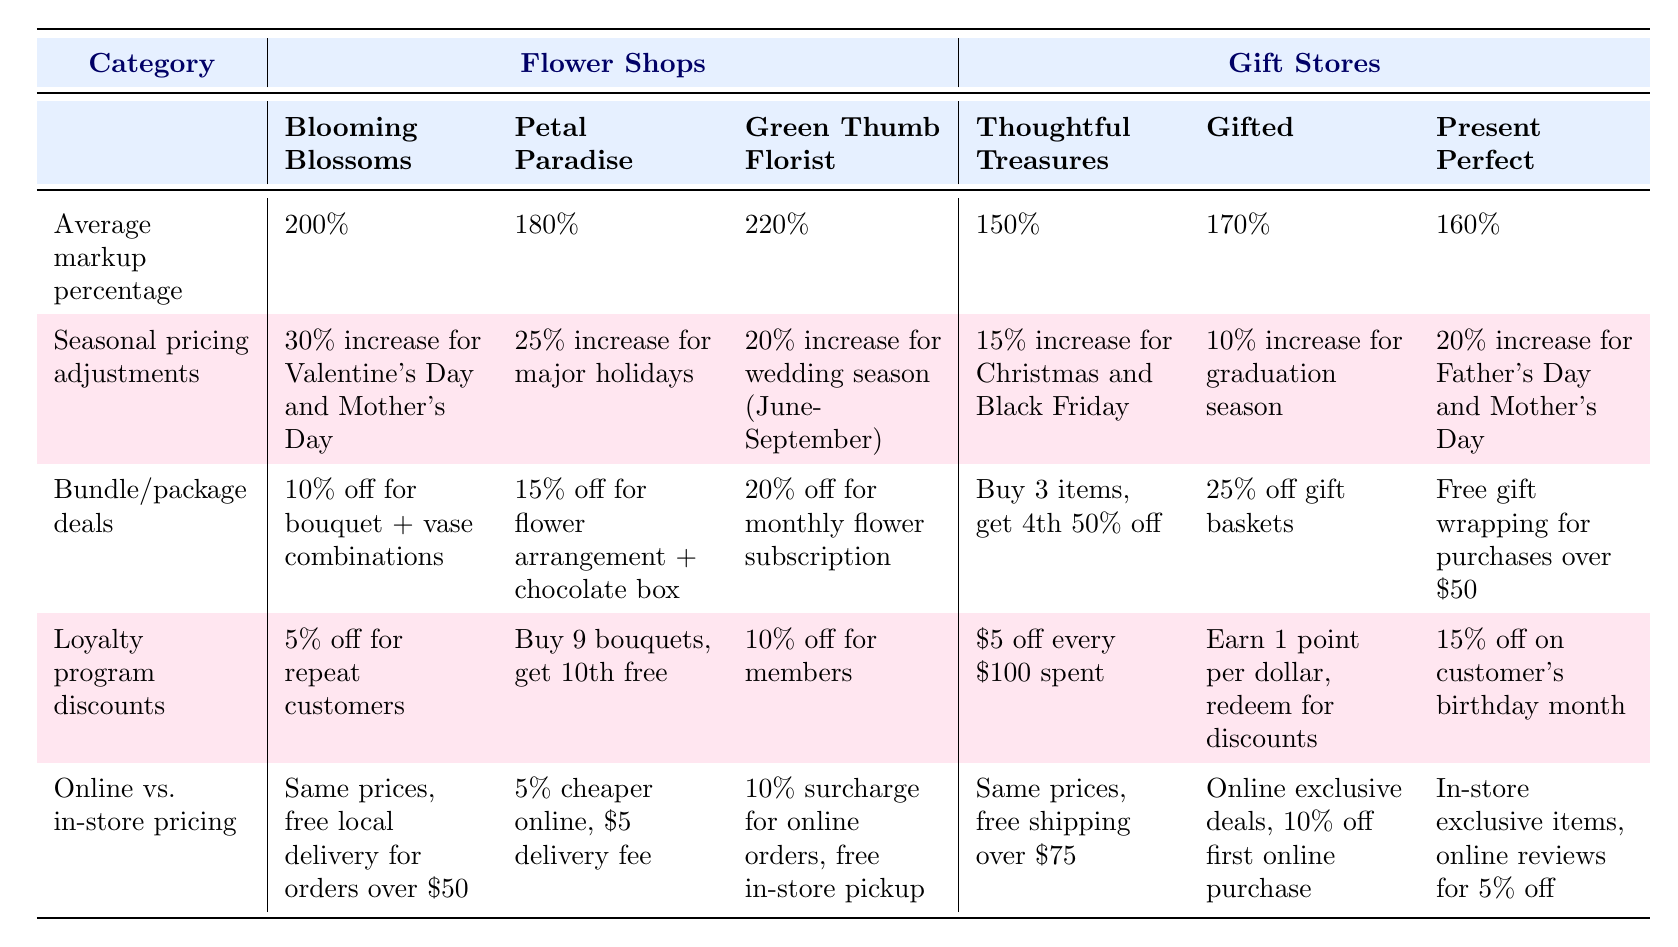What is the average markup percentage for flower shops? The table lists the average markup percentages for each flower shop: Blooming Blossoms (200%), Petal Paradise (180%), and Green Thumb Florist (220%). To find the average, sum these values: 200 + 180 + 220 = 600. Then divide by the number of shops (3): 600/3 = 200.
Answer: 200% Which flower shop offers the highest loyalty program discount? Comparing the loyalty discounts: Blooming Blossoms (5%), Petal Paradise (free 10th bouquet), Green Thumb Florist (10%), Thoughtful Treasures ($5 off), Gifted (points system), Present Perfect (15%). Checking these values, Present Perfect offers the best discount at 15%.
Answer: Present Perfect Is there a flower shop with seasonal pricing adjustments that exceed 30%? The table shows the seasonal pricing adjustments for flower shops: Blooming Blossoms (30%), Petal Paradise (25%), and Green Thumb Florist (20%). No seasonal adjustments exceed 30%, as the highest is exactly 30%.
Answer: No What is the bundle/package deal offered by Green Thumb Florist? The specific bundle deal for Green Thumb Florist is a 20% discount for a monthly flower subscription.
Answer: 20% off for monthly flower subscription Which type of store generally has a higher average markup percentage, flower shops or gift stores? The average markup percentages for flower shops are 200%, 180%, and 220%. For gift stores, they are 150%, 170%, and 160%. The average for flower shops is (200 + 180 + 220)/3 = 200%, while for gift stores it is (150 + 170 + 160)/3 = 160%. Since 200% is greater than 160%, flower shops have a higher average markup percentage.
Answer: Flower shops How much cheaper is Petal Paradise's online pricing compared to in-store pricing? Petal Paradise offers a 5% cheaper price online than in-store and has a $5 delivery fee applied. However, the comparison is simply about the percentage difference, which is 5%.
Answer: 5% cheaper Which gift store provides free gift wrapping as part of their bundle deals? Examining the bundle deals, Present Perfect offers free gift wrapping for purchases exceeding $50, while the other gift stores do not have this specific offer.
Answer: Present Perfect What is the seasonal pricing adjustment for Thoughtful Treasures during major holidays? The table states that Thoughtful Treasures has a 15% increase for Christmas and Black Friday as their seasonal pricing adjustment.
Answer: 15% increase for Christmas and Black Friday Is there a loyalty program discount that involves a points system? The table indicates that Gifted uses a points system where customers earn 1 point per dollar spent to be redeemed for discounts.
Answer: Yes 